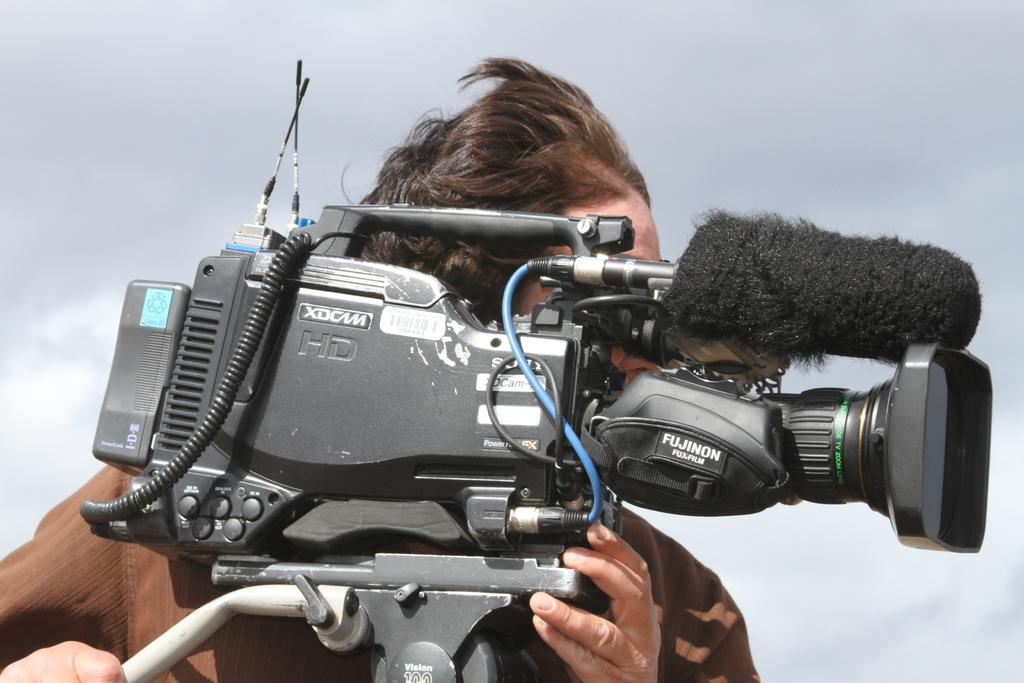What is the person in the image wearing? The person is wearing a brown color dress. What is the person holding in the image? The person is holding a camera. How would you describe the background of the image? The background of the image is ash colored. What type of grain can be seen falling in the image? There is no grain or falling motion present in the image. 